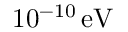<formula> <loc_0><loc_0><loc_500><loc_500>1 0 ^ { - 1 0 } \, e V</formula> 